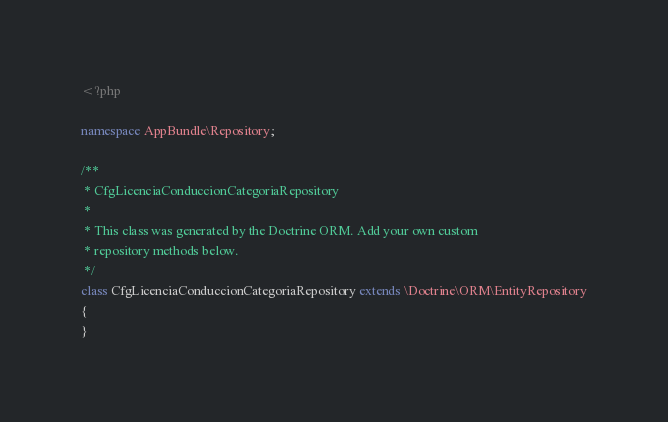Convert code to text. <code><loc_0><loc_0><loc_500><loc_500><_PHP_><?php

namespace AppBundle\Repository;

/**
 * CfgLicenciaConduccionCategoriaRepository
 *
 * This class was generated by the Doctrine ORM. Add your own custom
 * repository methods below.
 */
class CfgLicenciaConduccionCategoriaRepository extends \Doctrine\ORM\EntityRepository
{
}
</code> 